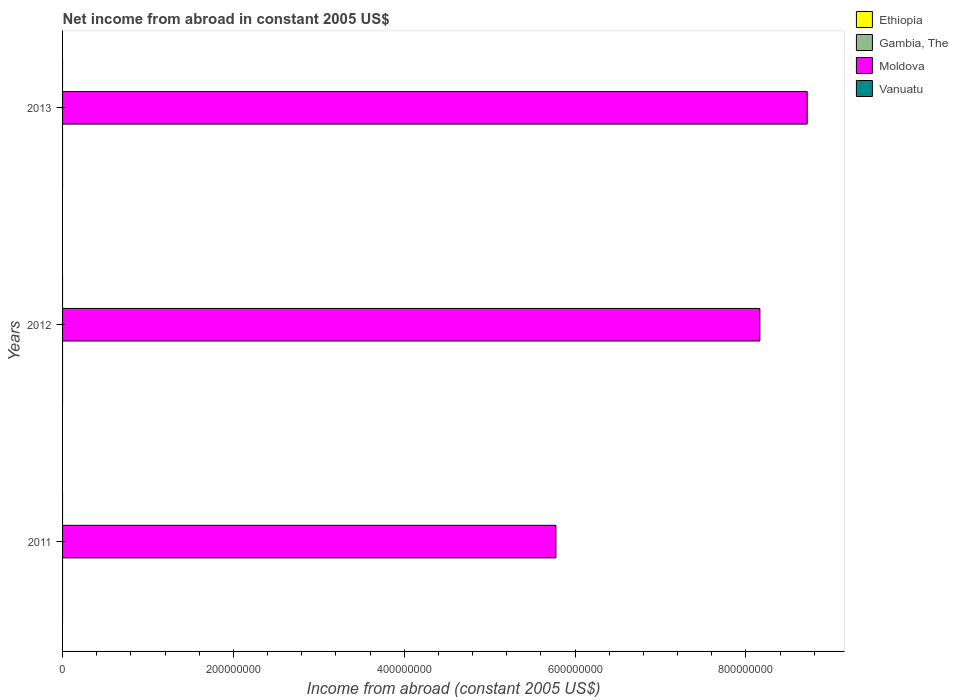How many different coloured bars are there?
Provide a succinct answer. 1. Are the number of bars per tick equal to the number of legend labels?
Offer a very short reply. No. How many bars are there on the 3rd tick from the bottom?
Offer a terse response. 1. What is the net income from abroad in Moldova in 2012?
Provide a short and direct response. 8.16e+08. Across all years, what is the minimum net income from abroad in Moldova?
Keep it short and to the point. 5.78e+08. What is the total net income from abroad in Moldova in the graph?
Your answer should be compact. 2.27e+09. What is the difference between the net income from abroad in Moldova in 2011 and that in 2012?
Keep it short and to the point. -2.39e+08. In how many years, is the net income from abroad in Moldova greater than the average net income from abroad in Moldova taken over all years?
Your answer should be very brief. 2. Is the sum of the net income from abroad in Moldova in 2011 and 2013 greater than the maximum net income from abroad in Vanuatu across all years?
Make the answer very short. Yes. Is it the case that in every year, the sum of the net income from abroad in Vanuatu and net income from abroad in Gambia, The is greater than the sum of net income from abroad in Ethiopia and net income from abroad in Moldova?
Your response must be concise. No. Is it the case that in every year, the sum of the net income from abroad in Gambia, The and net income from abroad in Moldova is greater than the net income from abroad in Ethiopia?
Your answer should be compact. Yes. How many bars are there?
Your answer should be very brief. 3. Are all the bars in the graph horizontal?
Ensure brevity in your answer.  Yes. Does the graph contain any zero values?
Keep it short and to the point. Yes. Does the graph contain grids?
Your answer should be very brief. No. Where does the legend appear in the graph?
Your response must be concise. Top right. How many legend labels are there?
Ensure brevity in your answer.  4. What is the title of the graph?
Keep it short and to the point. Net income from abroad in constant 2005 US$. Does "Mexico" appear as one of the legend labels in the graph?
Make the answer very short. No. What is the label or title of the X-axis?
Give a very brief answer. Income from abroad (constant 2005 US$). What is the label or title of the Y-axis?
Make the answer very short. Years. What is the Income from abroad (constant 2005 US$) of Moldova in 2011?
Your response must be concise. 5.78e+08. What is the Income from abroad (constant 2005 US$) in Ethiopia in 2012?
Your answer should be very brief. 0. What is the Income from abroad (constant 2005 US$) of Gambia, The in 2012?
Ensure brevity in your answer.  0. What is the Income from abroad (constant 2005 US$) of Moldova in 2012?
Offer a terse response. 8.16e+08. What is the Income from abroad (constant 2005 US$) of Moldova in 2013?
Keep it short and to the point. 8.72e+08. Across all years, what is the maximum Income from abroad (constant 2005 US$) in Moldova?
Your answer should be compact. 8.72e+08. Across all years, what is the minimum Income from abroad (constant 2005 US$) in Moldova?
Keep it short and to the point. 5.78e+08. What is the total Income from abroad (constant 2005 US$) in Ethiopia in the graph?
Your response must be concise. 0. What is the total Income from abroad (constant 2005 US$) of Gambia, The in the graph?
Ensure brevity in your answer.  0. What is the total Income from abroad (constant 2005 US$) in Moldova in the graph?
Make the answer very short. 2.27e+09. What is the difference between the Income from abroad (constant 2005 US$) of Moldova in 2011 and that in 2012?
Provide a short and direct response. -2.39e+08. What is the difference between the Income from abroad (constant 2005 US$) in Moldova in 2011 and that in 2013?
Keep it short and to the point. -2.94e+08. What is the difference between the Income from abroad (constant 2005 US$) of Moldova in 2012 and that in 2013?
Make the answer very short. -5.54e+07. What is the average Income from abroad (constant 2005 US$) in Ethiopia per year?
Ensure brevity in your answer.  0. What is the average Income from abroad (constant 2005 US$) of Moldova per year?
Provide a succinct answer. 7.55e+08. What is the average Income from abroad (constant 2005 US$) of Vanuatu per year?
Provide a short and direct response. 0. What is the ratio of the Income from abroad (constant 2005 US$) of Moldova in 2011 to that in 2012?
Provide a short and direct response. 0.71. What is the ratio of the Income from abroad (constant 2005 US$) of Moldova in 2011 to that in 2013?
Offer a very short reply. 0.66. What is the ratio of the Income from abroad (constant 2005 US$) of Moldova in 2012 to that in 2013?
Offer a terse response. 0.94. What is the difference between the highest and the second highest Income from abroad (constant 2005 US$) of Moldova?
Give a very brief answer. 5.54e+07. What is the difference between the highest and the lowest Income from abroad (constant 2005 US$) in Moldova?
Your answer should be very brief. 2.94e+08. 